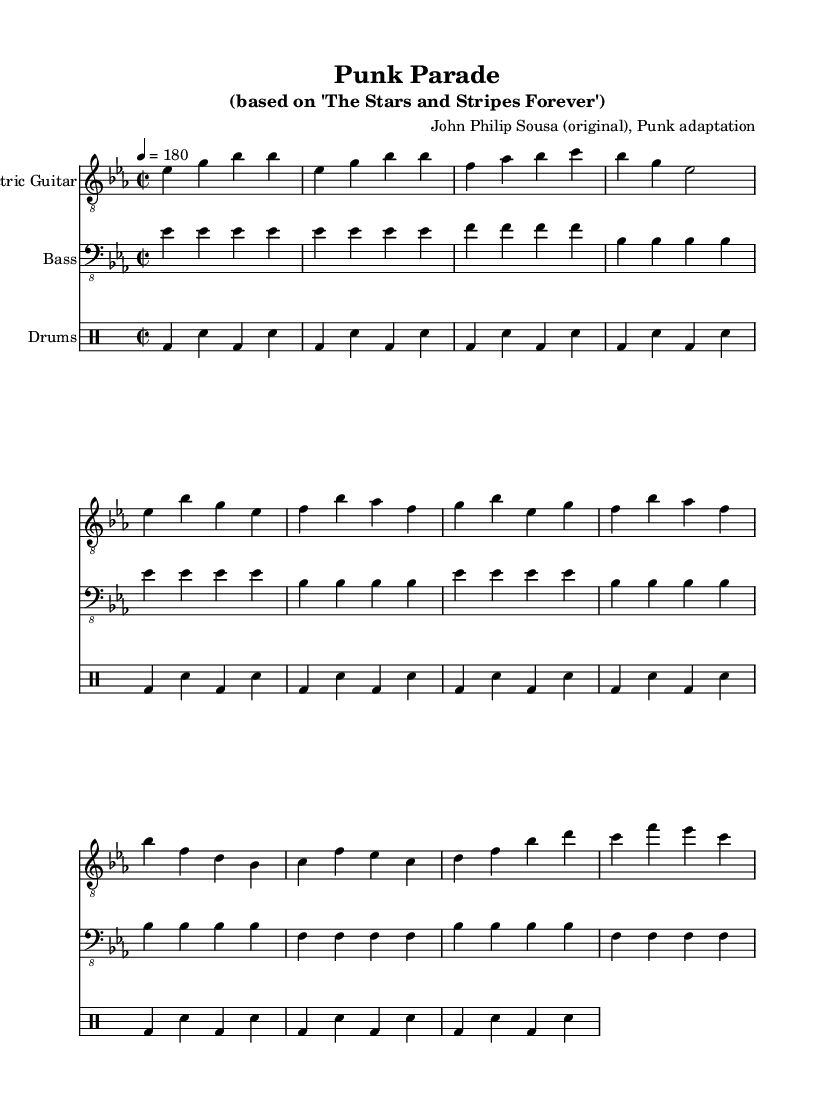What is the key signature of this music? The key signature is E-flat major, which has three flats: B-flat, E-flat, and A-flat. This is indicated by the key signature symbol at the beginning of the staff.
Answer: E-flat major What is the time signature of the piece? The time signature is 2/2, which indicates there are two beats in each measure and the half note gets one beat. This is shown at the beginning of the music.
Answer: 2/2 What is the tempo marking of the piece? The tempo marking indicates the piece should be played at a speed of 180 beats per minute, as described by the notation "4 = 180" at the start.
Answer: 180 How many measures are in the intro section? The intro section consists of four measures, as indicated by the count of the measure lines in the corresponding part of the sheet music.
Answer: 4 What is the primary rhythm pattern used in the drums? The primary rhythm pattern in the drums consists of a bass drum followed by a snare drum, which is observed throughout the drumming section. The repeated pattern of one bass, one snare is characteristic of punk music.
Answer: bass-sn What instrument plays the melody in this piece? The melody is primarily played by the electric guitar, which is indicated by the staff labeled with "Electric Guitar." The notes in the staff represent the main melodic line.
Answer: Electric Guitar What genre does this arrangement belong to? This arrangement is categorized as Punk due to its adaptation style and rhythmic patterns that align with the punk genre's characteristics, emphasizing speed and energy.
Answer: Punk 